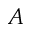Convert formula to latex. <formula><loc_0><loc_0><loc_500><loc_500>A</formula> 